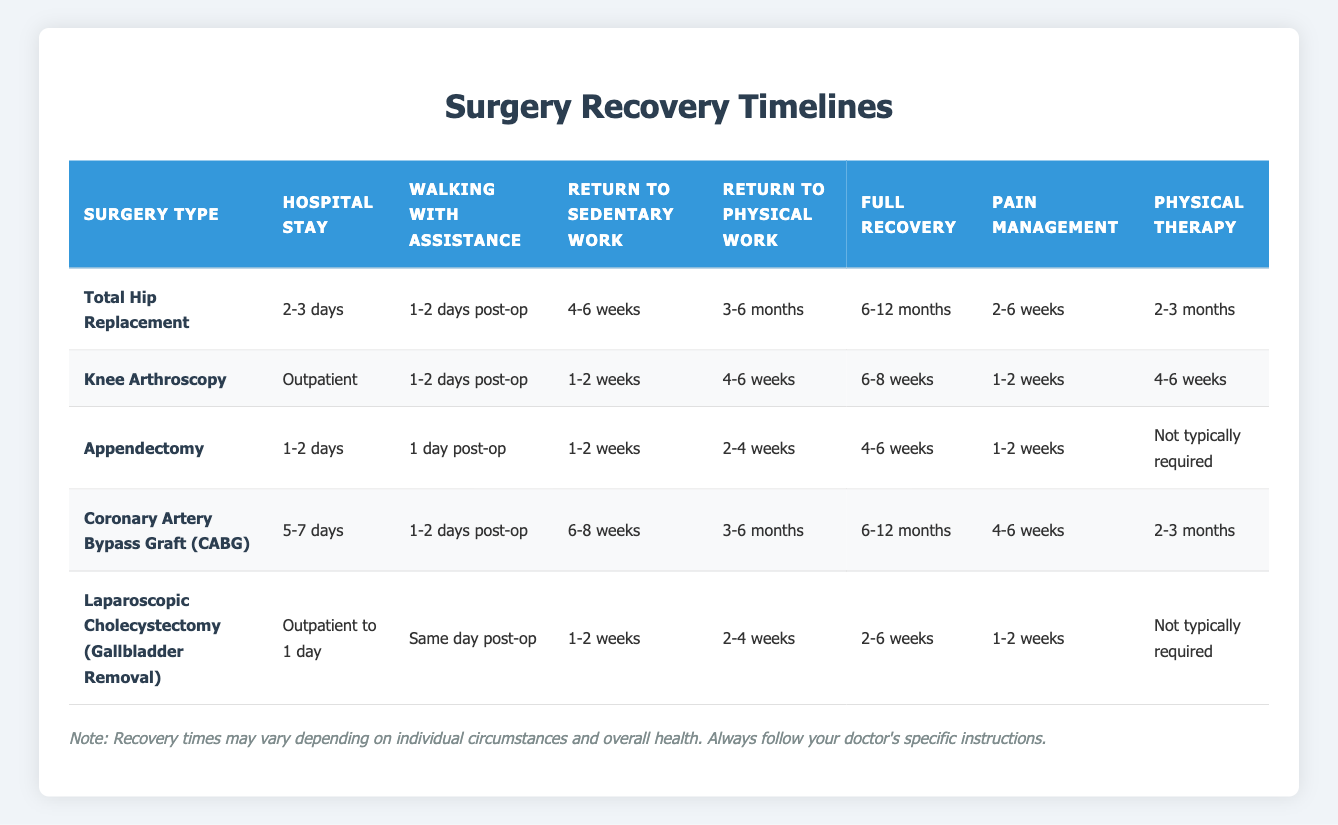What is the hospital stay duration for a Total Hip Replacement? The table states that the hospital stay for a Total Hip Replacement is "2-3 days." This is found directly in the corresponding row under the "Hospital Stay" column for this surgery type.
Answer: 2-3 days How long after a Knee Arthroscopy can a patient expect to return to sedentary work? According to the table, the return to sedentary work after a Knee Arthroscopy is "1-2 weeks." This information is directly available in the row corresponding to Knee Arthroscopy under the "Return to Sedentary Work" column.
Answer: 1-2 weeks Is physical therapy typically required after an Appendectomy? The table indicates that physical therapy is "Not typically required" after an Appendectomy. This is found in the row for Appendectomy in the "Physical Therapy" column, confirming that physical therapy is not a usual requirement for this procedure.
Answer: No What is the average full recovery time across these surgeries? The full recovery times listed are: 6-12 months for Total Hip Replacement, 6-8 weeks for Knee Arthroscopy, 4-6 weeks for Appendectomy, 6-12 months for CABG, and 2-6 weeks for Laparoscopic Cholecystectomy. Converting to weeks: Total Hip Replacement (months to weeks: 24-52), Knee Arthroscopy (6-8 weeks), Appendectomy (4-6 weeks), CABG (24-52 weeks), and Laparoscopic Cholecystectomy (2-6 weeks). The sum is 24 + 8 + 6 + 24 + 2 = 64 weeks (min) and 52 + 6 + 4 + 52 + 6 = 120 weeks (max). Therefore, the average range is 64/5 = 12.8 weeks (min) and 120/5 = 24 weeks (max).
Answer: 12.8 to 24 weeks What is the longest pain management duration for any of these surgeries? Checking the pain management durations listed: 2-6 weeks for Total Hip Replacement, 1-2 weeks for Knee Arthroscopy, 1-2 weeks for Appendectomy, 4-6 weeks for CABG, and 1-2 weeks for Laparoscopic Cholecystectomy. The maximum duration is 6 weeks for Total Hip Replacement and CABG. Since both are tied, the answer is based on the maximum value observed.
Answer: 6 weeks 